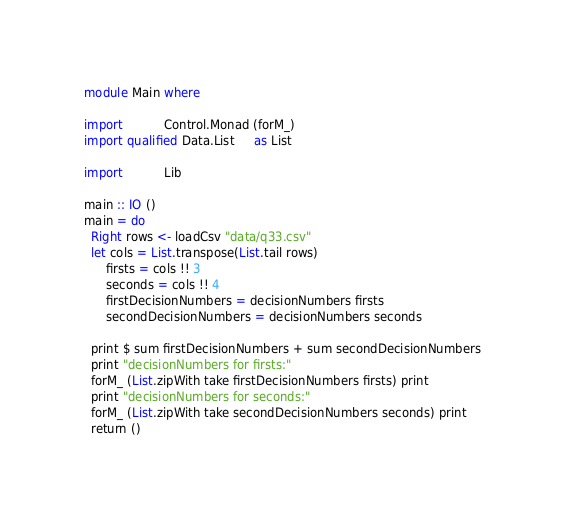<code> <loc_0><loc_0><loc_500><loc_500><_Haskell_>module Main where

import           Control.Monad (forM_)
import qualified Data.List     as List

import           Lib

main :: IO ()
main = do
  Right rows <- loadCsv "data/q33.csv"
  let cols = List.transpose(List.tail rows)
      firsts = cols !! 3
      seconds = cols !! 4
      firstDecisionNumbers = decisionNumbers firsts
      secondDecisionNumbers = decisionNumbers seconds

  print $ sum firstDecisionNumbers + sum secondDecisionNumbers
  print "decisionNumbers for firsts:"
  forM_ (List.zipWith take firstDecisionNumbers firsts) print
  print "decisionNumbers for seconds:"
  forM_ (List.zipWith take secondDecisionNumbers seconds) print
  return ()
</code> 